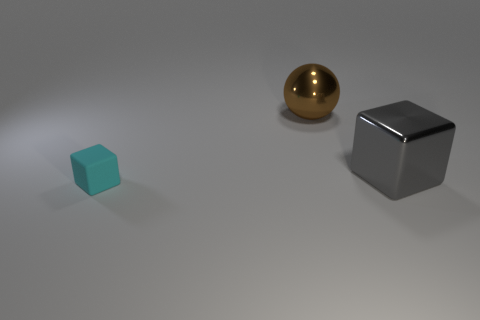Does the brown sphere have the same material as the block behind the cyan matte thing?
Offer a very short reply. Yes. What is the material of the big cube?
Provide a short and direct response. Metal. What material is the cube in front of the cube to the right of the small cyan object on the left side of the big brown metal ball?
Provide a succinct answer. Rubber. There is a rubber thing; is its color the same as the block that is behind the cyan rubber object?
Give a very brief answer. No. Are there any other things that have the same shape as the brown metal thing?
Give a very brief answer. No. What color is the large shiny thing that is to the right of the shiny object that is on the left side of the large metal cube?
Your answer should be very brief. Gray. What number of big shiny spheres are there?
Your answer should be very brief. 1. How many metallic objects are either gray things or big brown blocks?
Offer a very short reply. 1. What number of big metal spheres are the same color as the tiny matte thing?
Your answer should be compact. 0. What is the block that is on the left side of the cube right of the large metal sphere made of?
Keep it short and to the point. Rubber. 